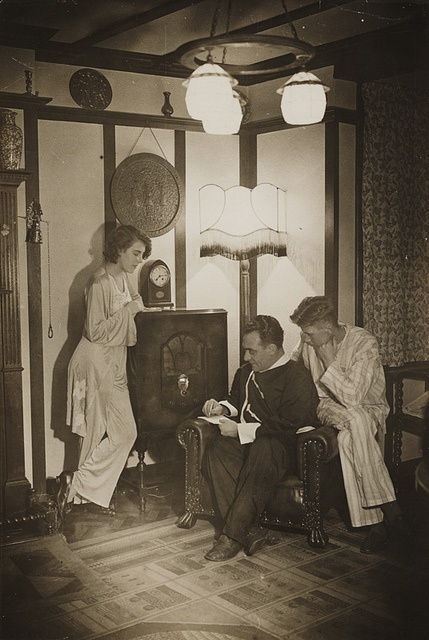Describe the objects in this image and their specific colors. I can see people in black and gray tones, people in black, tan, and gray tones, people in black, gray, and tan tones, chair in black and gray tones, and clock in black, tan, and gray tones in this image. 